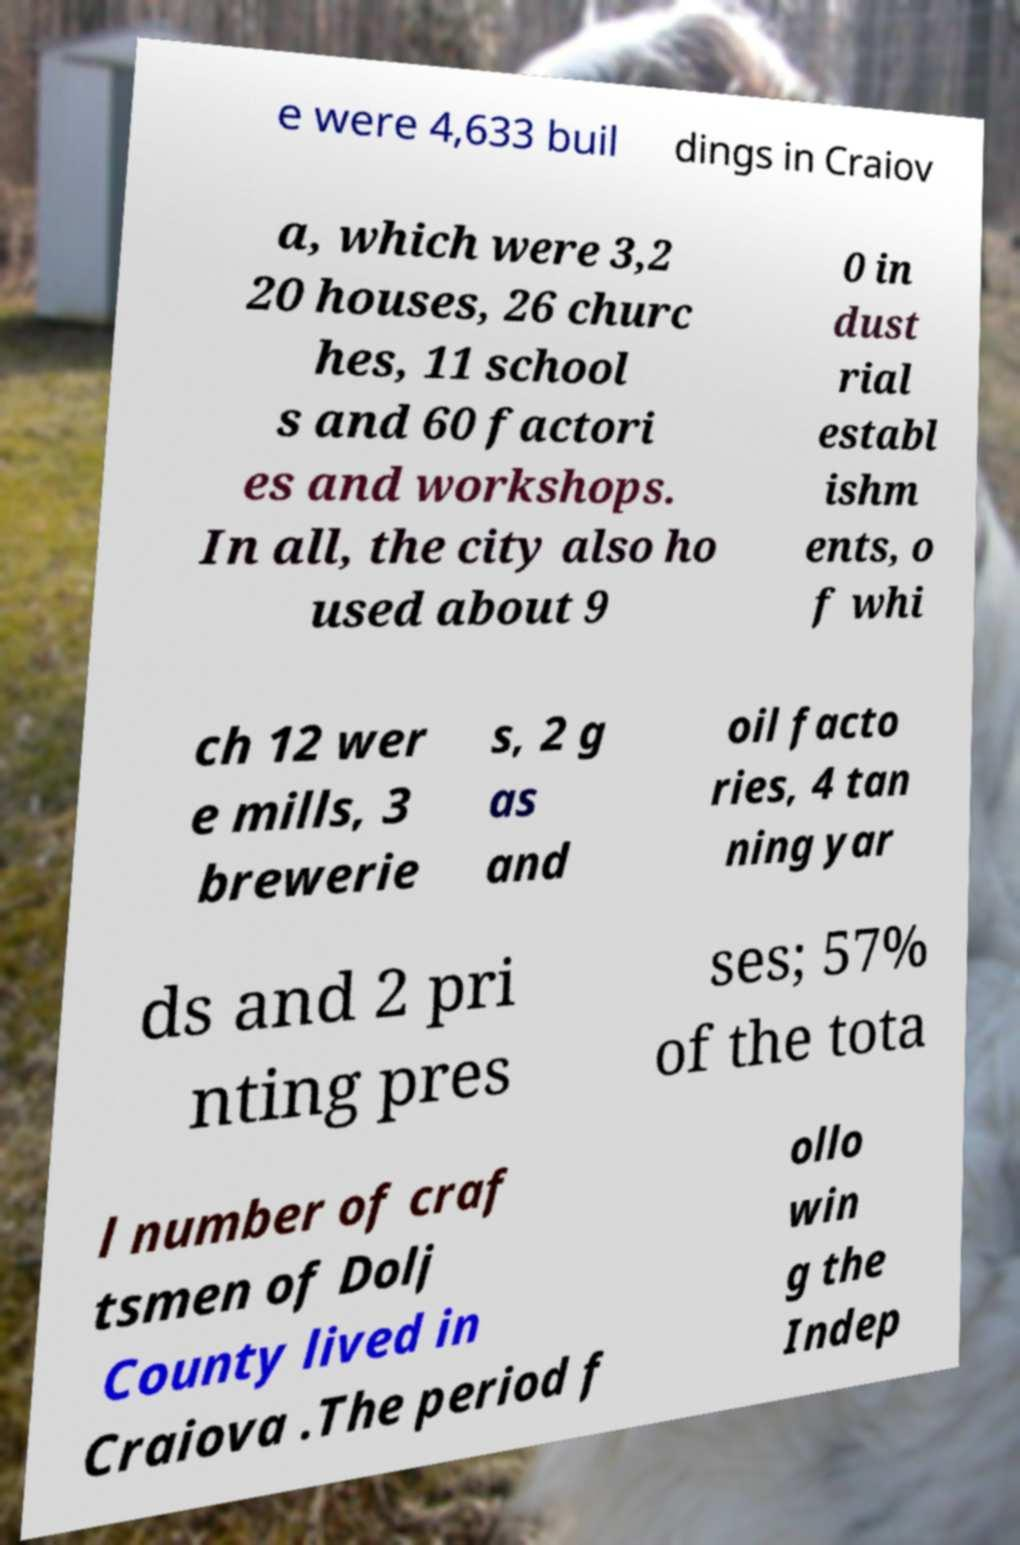There's text embedded in this image that I need extracted. Can you transcribe it verbatim? e were 4,633 buil dings in Craiov a, which were 3,2 20 houses, 26 churc hes, 11 school s and 60 factori es and workshops. In all, the city also ho used about 9 0 in dust rial establ ishm ents, o f whi ch 12 wer e mills, 3 brewerie s, 2 g as and oil facto ries, 4 tan ning yar ds and 2 pri nting pres ses; 57% of the tota l number of craf tsmen of Dolj County lived in Craiova .The period f ollo win g the Indep 